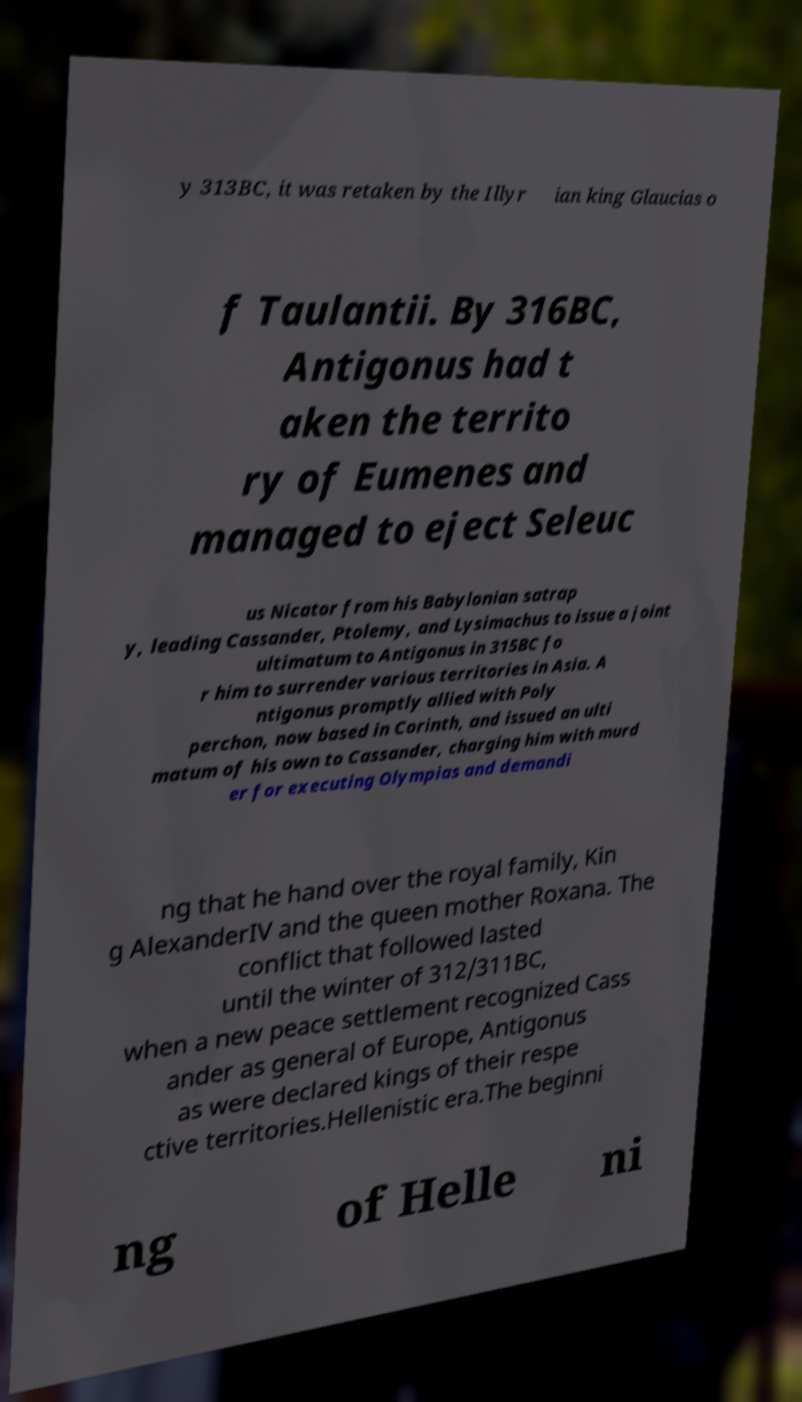Can you read and provide the text displayed in the image?This photo seems to have some interesting text. Can you extract and type it out for me? y 313BC, it was retaken by the Illyr ian king Glaucias o f Taulantii. By 316BC, Antigonus had t aken the territo ry of Eumenes and managed to eject Seleuc us Nicator from his Babylonian satrap y, leading Cassander, Ptolemy, and Lysimachus to issue a joint ultimatum to Antigonus in 315BC fo r him to surrender various territories in Asia. A ntigonus promptly allied with Poly perchon, now based in Corinth, and issued an ulti matum of his own to Cassander, charging him with murd er for executing Olympias and demandi ng that he hand over the royal family, Kin g AlexanderIV and the queen mother Roxana. The conflict that followed lasted until the winter of 312/311BC, when a new peace settlement recognized Cass ander as general of Europe, Antigonus as were declared kings of their respe ctive territories.Hellenistic era.The beginni ng of Helle ni 